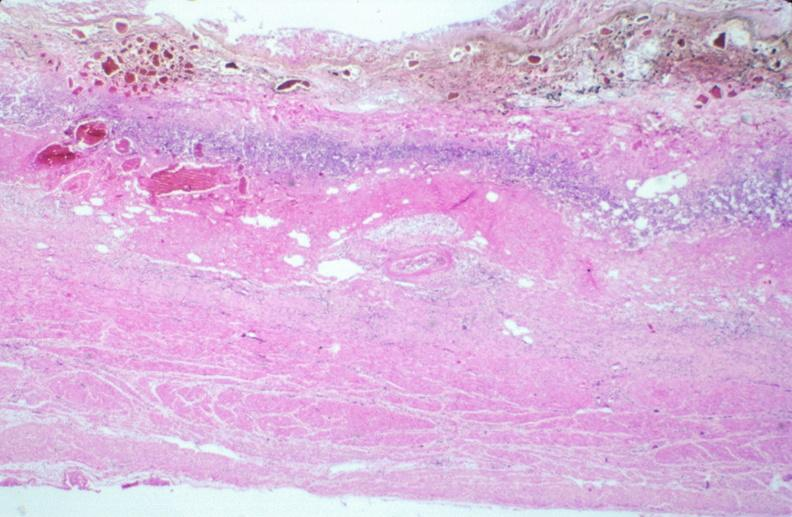what is present?
Answer the question using a single word or phrase. Gastrointestinal 